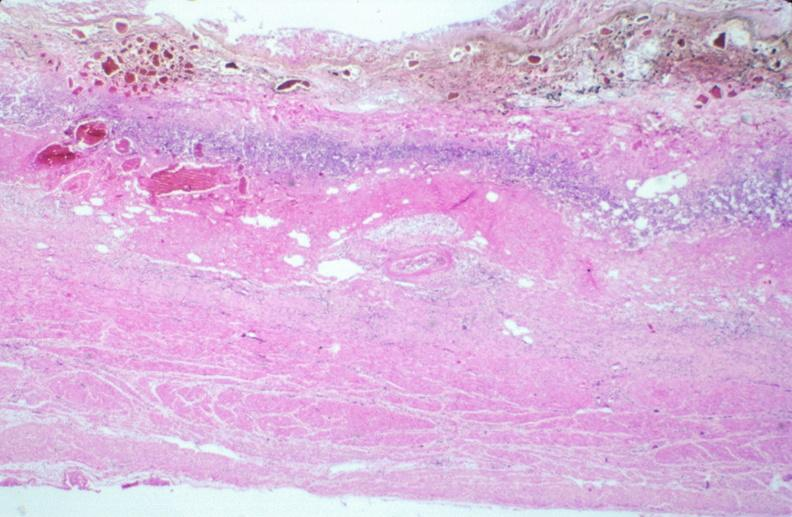what is present?
Answer the question using a single word or phrase. Gastrointestinal 